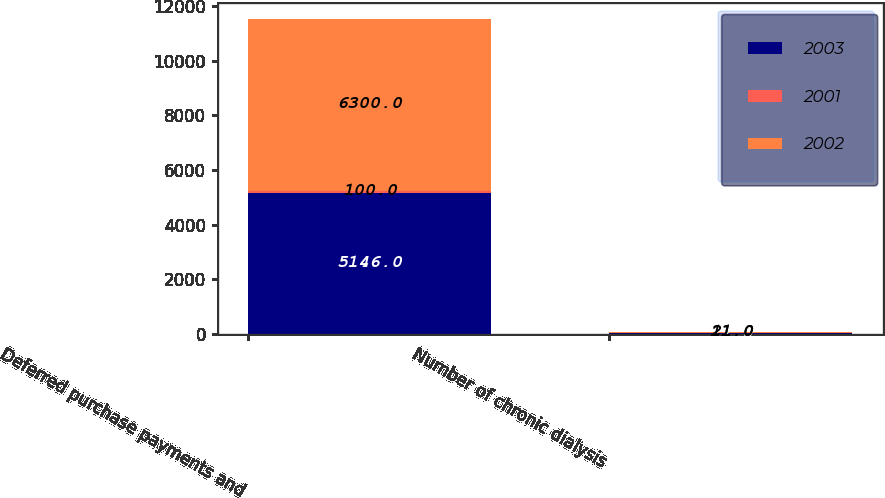Convert chart to OTSL. <chart><loc_0><loc_0><loc_500><loc_500><stacked_bar_chart><ecel><fcel>Deferred purchase payments and<fcel>Number of chronic dialysis<nl><fcel>2003<fcel>5146<fcel>27<nl><fcel>2001<fcel>100<fcel>11<nl><fcel>2002<fcel>6300<fcel>21<nl></chart> 